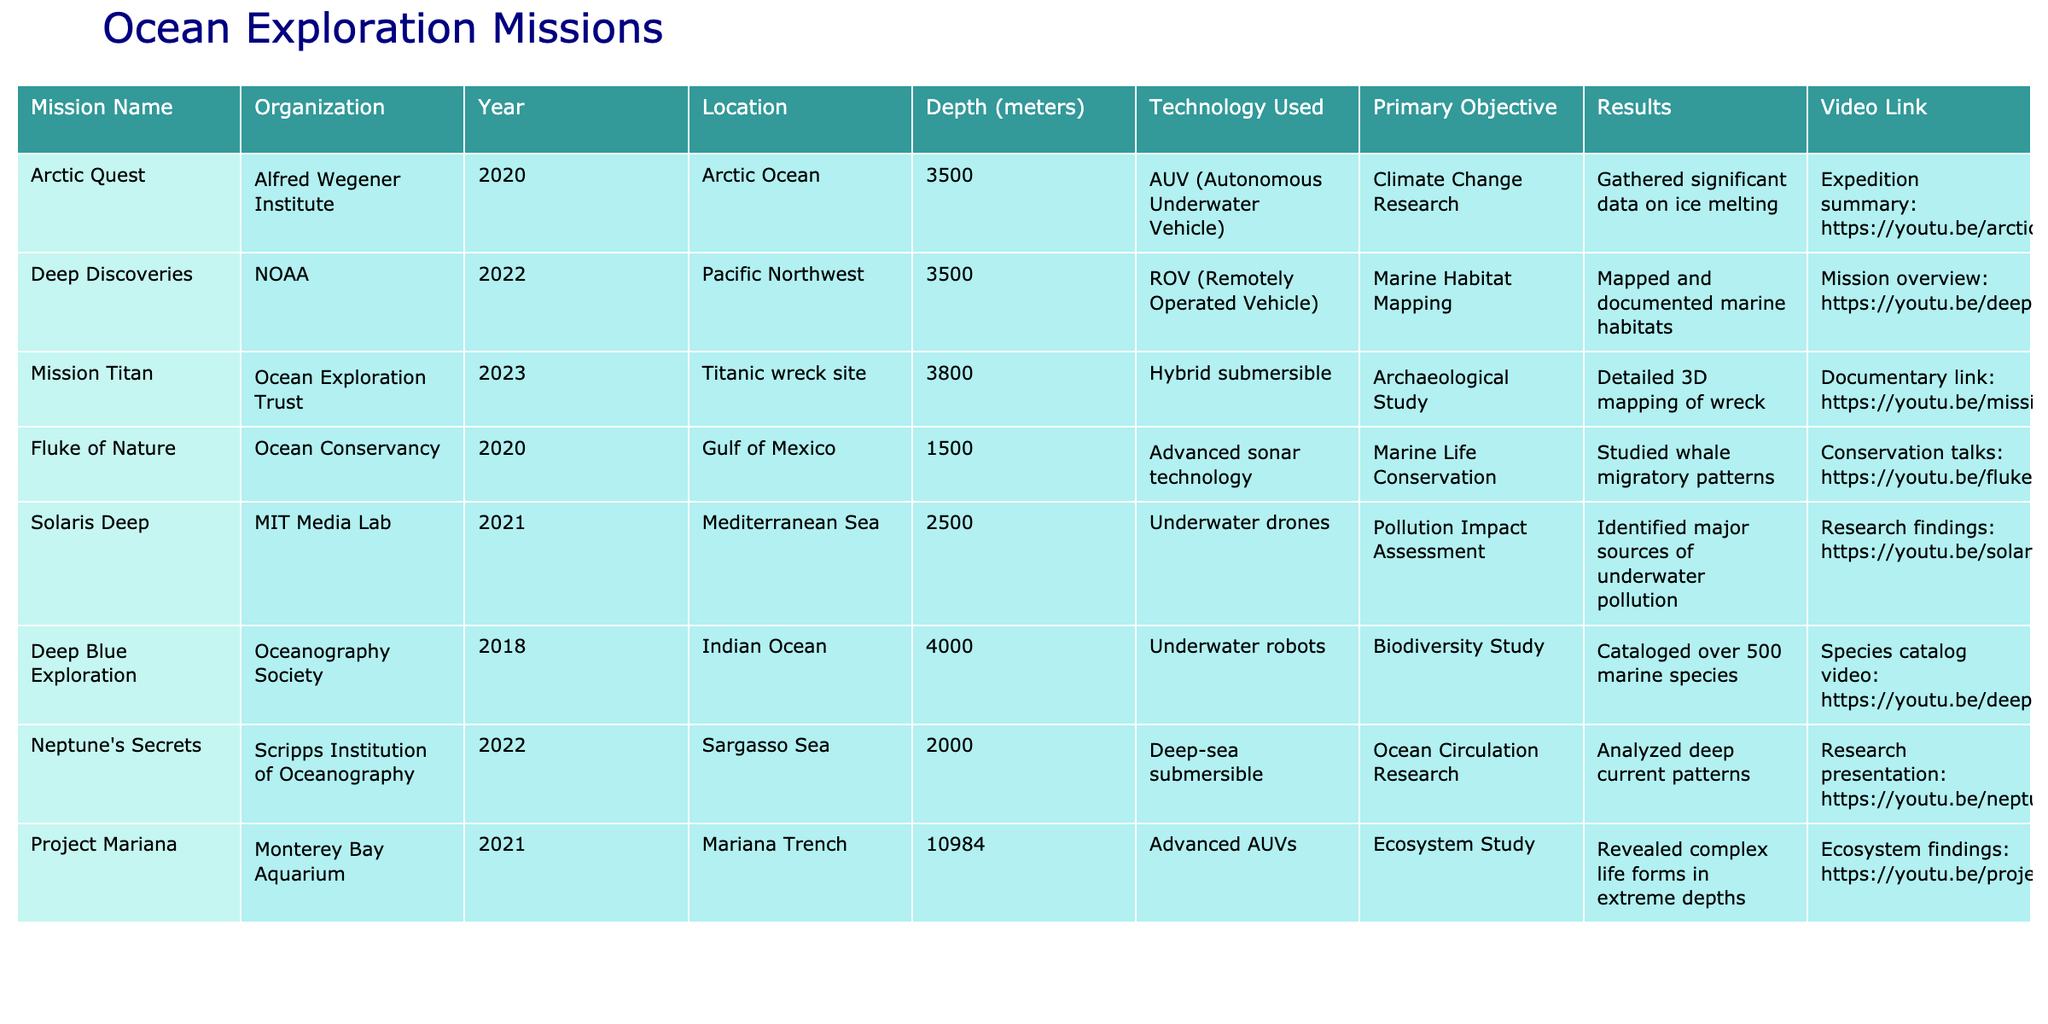What is the deepest mission listed in the table? The depth of each mission is shown in the table. By comparing the "Depth (meters)" column, "Project Mariana" has the highest depth of 10,984 meters.
Answer: 10,984 meters Which organization conducted a marine habitat mapping mission? The table lists organizations with their corresponding missions. By checking the "Primary Objective" for each organization, NOAA conducted the "Deep Discoveries" mission for marine habitat mapping.
Answer: NOAA How many missions were focused on conservation or ecosystems? By reviewing the "Primary Objective" column, "Fluke of Nature" is focused on marine life conservation and "Project Mariana" on ecosystem study, making a total of two missions focused on these areas.
Answer: 2 Did any missions use AUV technology? By scanning the "Technology Used" column, both "Arctic Quest" and "Project Mariana" utilized AUV technology for their missions, confirming that at least two missions used this technology.
Answer: Yes What was the average depth of missions conducted in the Pacific region? The missions in the Pacific are “Deep Discoveries” at 3,500 meters and “Fluke of Nature” at 1,500 meters. To find the average, calculate (3,500 + 1,500) / 2 = 2,500 meters.
Answer: 2,500 meters What is the primary objective of the mission conducted by MIT Media Lab? The table shows that the primary objective of “Solaris Deep” by MIT Media Lab is "Pollution Impact Assessment."
Answer: Pollution Impact Assessment Which two missions conducted research on marine species or biodiversity? The "Deep Blue Exploration" mission focused on biodiversity and cataloged marine species, while "Fluke of Nature" studied marine life conservation. Both missions are related to marine species.
Answer: Deep Blue Exploration, Fluke of Nature What is the total number of missions listed from the Ocean Exploration Trust? Only one mission, "Mission Titan," is listed from the Ocean Exploration Trust. Thus, the total number of missions is one.
Answer: 1 Which mission occurred in the Arctic region, and what was its primary objective? The mission "Arctic Quest" is listed in the Arctic region, and its primary objective was "Climate Change Research."
Answer: Arctic Quest, Climate Change Research Is there any mission that focused exclusively on archaeological studies? “Mission Titan” by Ocean Exploration Trust is explicitly focused on archaeological studies, confirming that there is at least one such mission.
Answer: Yes 